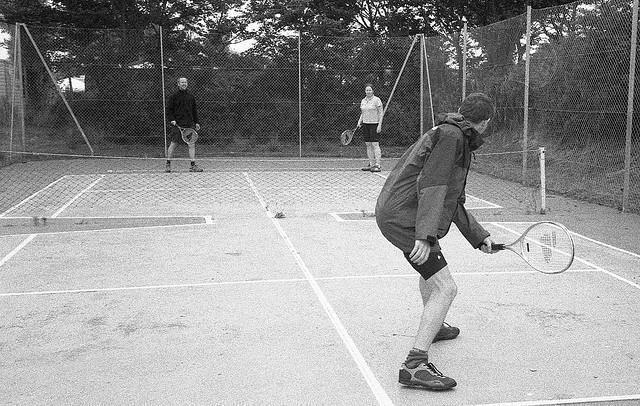How many ducks have orange hats?
Give a very brief answer. 0. 